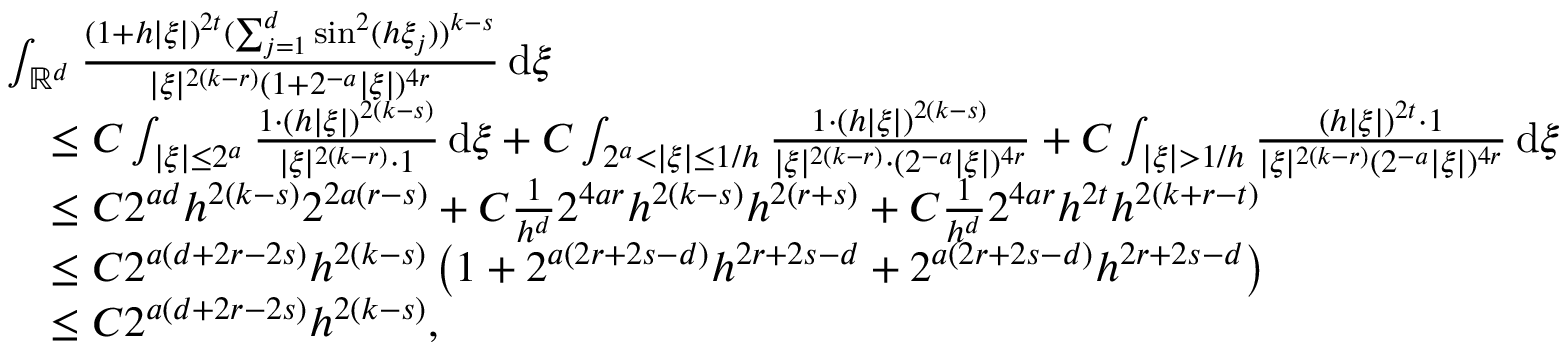Convert formula to latex. <formula><loc_0><loc_0><loc_500><loc_500>\begin{array} { r l } & { \int _ { \mathbb { R } ^ { d } } \frac { ( 1 + h | \xi | ) ^ { 2 t } ( \sum _ { j = 1 } ^ { d } \sin ^ { 2 } ( h \xi _ { j } ) ) ^ { k - s } } { | \xi | ^ { 2 ( k - r ) } ( 1 + 2 ^ { - a } | \xi | ) ^ { 4 r } } \, d \xi } \\ & { \quad \leq C \int _ { | \xi | \leq 2 ^ { a } } \frac { 1 \cdot ( h | \xi | ) ^ { 2 ( k - s ) } } { | \xi | ^ { 2 ( k - r ) } \cdot 1 } \, d \xi + C \int _ { 2 ^ { a } < | \xi | \leq 1 / h } \frac { 1 \cdot ( h | \xi | ) ^ { 2 ( k - s ) } } { | \xi | ^ { 2 ( k - r ) } \cdot ( 2 ^ { - a } | \xi | ) ^ { 4 r } } + C \int _ { | \xi | > 1 / h } \frac { ( h | \xi | ) ^ { 2 t } \cdot 1 } { | \xi | ^ { 2 ( k - r ) } ( 2 ^ { - a } | \xi | ) ^ { 4 r } } \, d \xi } \\ & { \quad \leq C 2 ^ { a d } h ^ { 2 ( k - s ) } 2 ^ { 2 a ( r - s ) } + C \frac { 1 } { h ^ { d } } 2 ^ { 4 a r } h ^ { 2 ( k - s ) } h ^ { 2 ( r + s ) } + C \frac { 1 } { h ^ { d } } 2 ^ { 4 a r } h ^ { 2 t } h ^ { 2 ( k + r - t ) } } \\ & { \quad \leq C 2 ^ { a ( d + 2 r - 2 s ) } h ^ { 2 ( k - s ) } \left ( 1 + 2 ^ { a ( 2 r + 2 s - d ) } h ^ { 2 r + 2 s - d } + 2 ^ { a ( 2 r + 2 s - d ) } h ^ { 2 r + 2 s - d } \right ) } \\ & { \quad \leq C 2 ^ { a ( d + 2 r - 2 s ) } h ^ { 2 ( k - s ) } , } \end{array}</formula> 